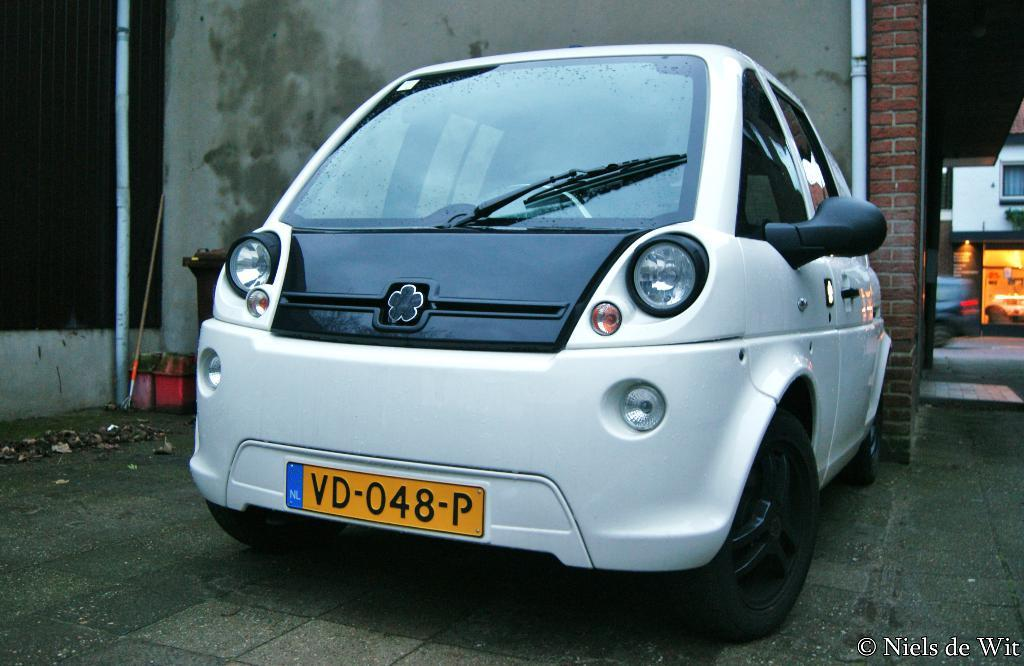What is the main subject of the image? The main subject of the image is a car. Where is the car located in relation to other objects in the image? The car is in front of a wall. What can be seen on the wall? There are pipes on the wall. What is visible on the right side of the image? There is a house on the right side of the image. What type of health benefits does the car provide in the image? The car does not provide any health benefits in the image; it is a stationary object. 